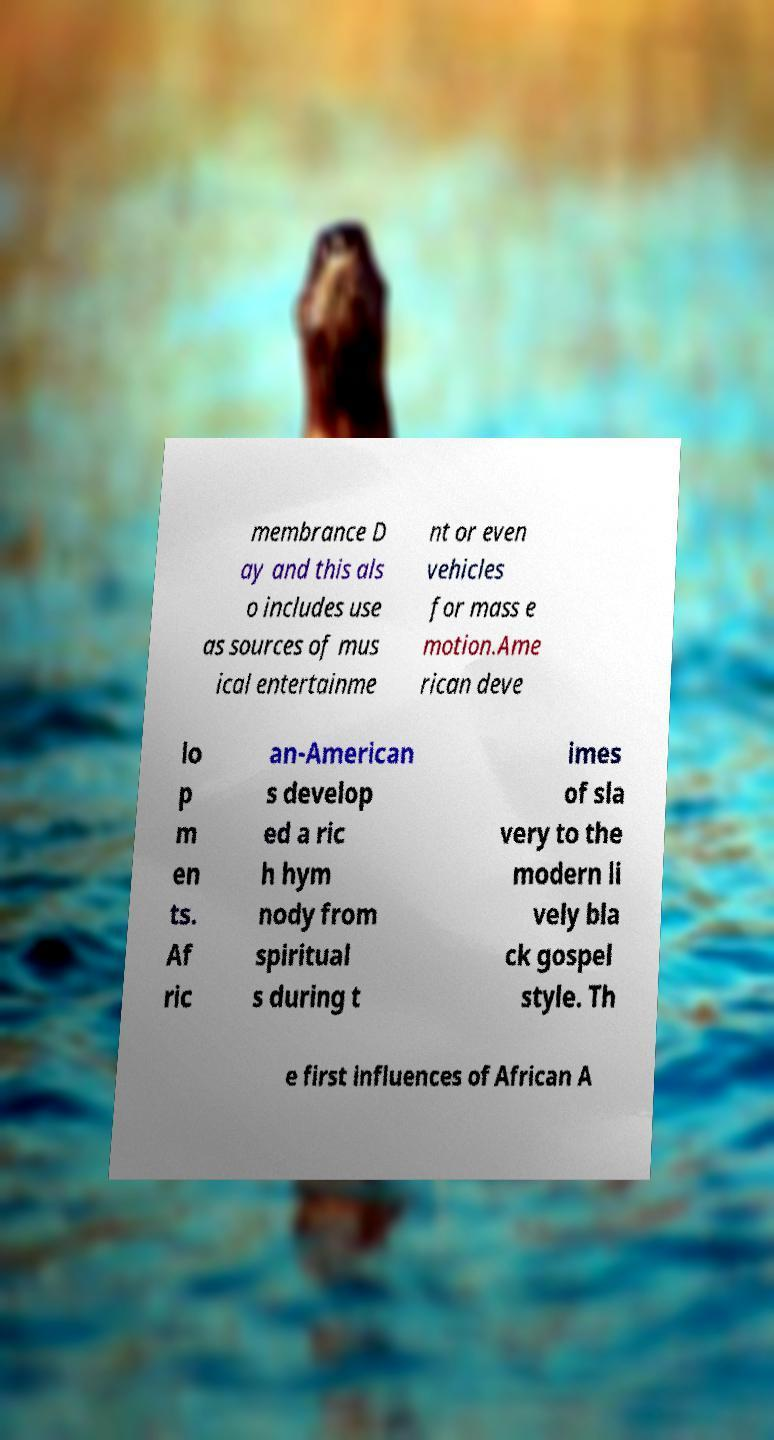Can you read and provide the text displayed in the image?This photo seems to have some interesting text. Can you extract and type it out for me? membrance D ay and this als o includes use as sources of mus ical entertainme nt or even vehicles for mass e motion.Ame rican deve lo p m en ts. Af ric an-American s develop ed a ric h hym nody from spiritual s during t imes of sla very to the modern li vely bla ck gospel style. Th e first influences of African A 